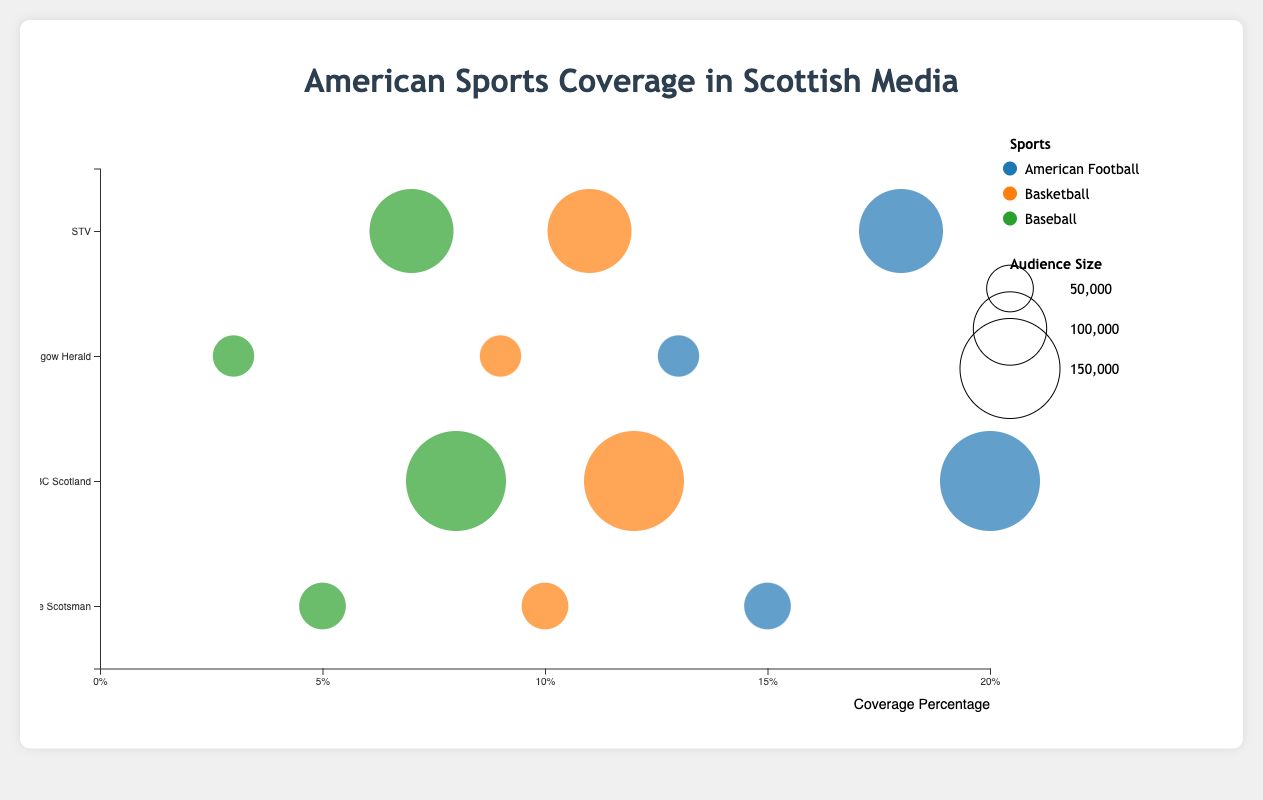Which sport has the highest coverage percentage on BBC Scotland? By looking at the data points for BBC Scotland, compare the coverage percentages for American Football, Basketball, and Baseball. American Football has 20%, Basketball has 12%, and Baseball has 8%. The highest is American Football.
Answer: American Football What is the coverage percentage of Basketball in both newspaper types? Looking at the data points for Newspapers (The Scotsman and Glasgow Herald), the coverage percentages for Basketball are 10% in The Scotsman and 9% in the Glasgow Herald.
Answer: 10% and 9% Which publication provides the least coverage for Baseball? Comparing the coverage percentages of Baseball across all publications, The Glasgow Herald covers Baseball at 3%, which is the lowest.
Answer: Glasgow Herald Which medium has a larger audience size on average, Television or Newspapers? Calculate the average audience sizes for Television (BBC Scotland: 150,000 and STV: 120,000) and Newspapers (The Scotsman: 50,000 and Glasgow Herald: 40,000). For Television, the average is (150,000 + 120,000) / 2 = 135,000. For Newspapers, the average is (50,000 + 40,000) / 2 = 45,000.
Answer: Television How does the coverage percentage of American Football in The Scotsman compare to that in STV? Compare the percentages directly. The Scotsman covers American Football at 15%, while STV covers it at 18%. Therefore, STV covers it more.
Answer: STV covers more What's the total audience size for all American Football coverage across all publications? Add the audience sizes of all publications covering American Football: 50,000 (The Scotsman) + 150,000 (BBC Scotland) + 40,000 (Glasgow Herald) + 120,000 (STV) = 360,000.
Answer: 360,000 Which sport has the smallest bubble size overall? By analyzing the bubble sizes, we observe that Baseball generally has smaller bubble sizes compared to American Football and Basketball, indicating smaller audience sizes.
Answer: Baseball Is there any sport that has the same coverage percentage across all publications? Check the coverage percentages for each sport across all publications. All have varying percentages. Hence, no sport has the same coverage across all publications.
Answer: No What's the difference in baseball coverage percentage between The Scotsman and BBC Scotland? Subtract Baseball's coverage percentage in The Scotsman (5%) from that in BBC Scotland (8%). The difference is 8% - 5% = 3%.
Answer: 3% 